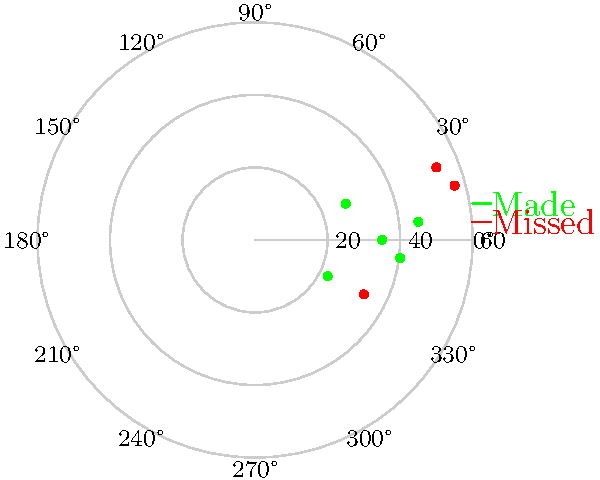As a local sports reporter, you're analyzing the field goal performance of your town's high school football team's kicker. The polar scatter plot above shows the kicker's attempts, where the radial distance represents the kick distance in yards, and the angle represents the direction (with 0° being straight down the middle). Green dots indicate successful kicks, while red dots show misses. What percentage of kicks from 40 yards or more were successful? To solve this problem, we need to follow these steps:

1. Identify kicks from 40 yards or more:
   - 45 yards at 5°
   - 40 yards at -5°
   - 50 yards at 20°
   - 55 yards at 15°

2. Count the total number of kicks from 40 yards or more:
   There are 4 kicks in total.

3. Count the number of successful kicks (green dots) from 40 yards or more:
   - 45 yards at 5° (successful)
   - 40 yards at -5° (successful)
   - 50 yards at 20° (missed)
   - 55 yards at 15° (missed)
   There are 2 successful kicks.

4. Calculate the percentage of successful kicks:
   $\text{Percentage} = \frac{\text{Number of successful kicks}}{\text{Total number of kicks}} \times 100\%$
   $\text{Percentage} = \frac{2}{4} \times 100\% = 50\%$

Therefore, 50% of kicks from 40 yards or more were successful.
Answer: 50% 